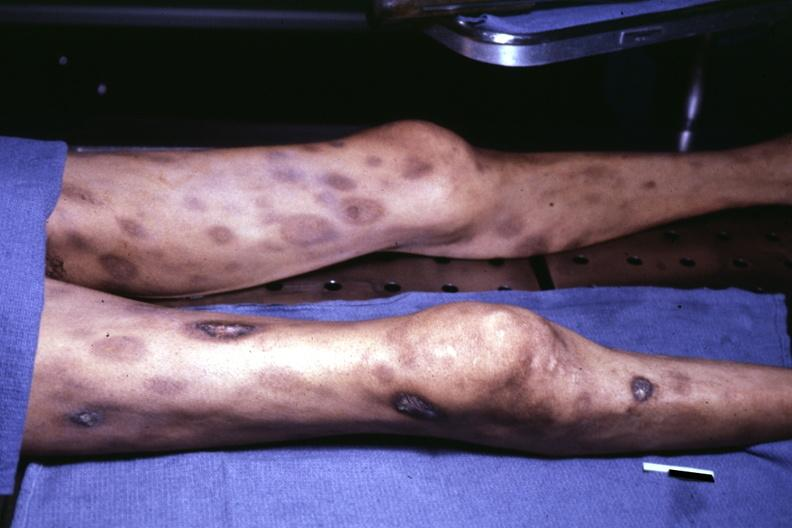does view of thighs and legs at autopsy ecchymose with central necrosis?
Answer the question using a single word or phrase. Yes 